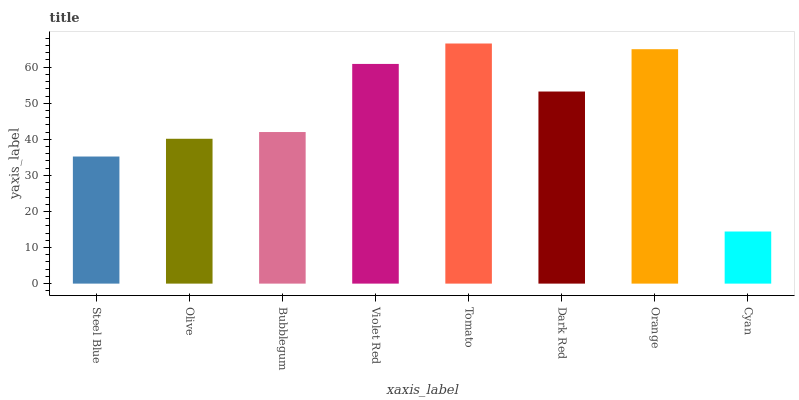Is Cyan the minimum?
Answer yes or no. Yes. Is Tomato the maximum?
Answer yes or no. Yes. Is Olive the minimum?
Answer yes or no. No. Is Olive the maximum?
Answer yes or no. No. Is Olive greater than Steel Blue?
Answer yes or no. Yes. Is Steel Blue less than Olive?
Answer yes or no. Yes. Is Steel Blue greater than Olive?
Answer yes or no. No. Is Olive less than Steel Blue?
Answer yes or no. No. Is Dark Red the high median?
Answer yes or no. Yes. Is Bubblegum the low median?
Answer yes or no. Yes. Is Steel Blue the high median?
Answer yes or no. No. Is Steel Blue the low median?
Answer yes or no. No. 